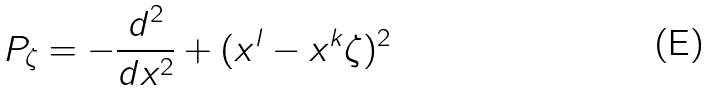Convert formula to latex. <formula><loc_0><loc_0><loc_500><loc_500>P _ { \zeta } = - \frac { d ^ { 2 } } { d x ^ { 2 } } + ( x ^ { l } - x ^ { k } \zeta ) ^ { 2 }</formula> 